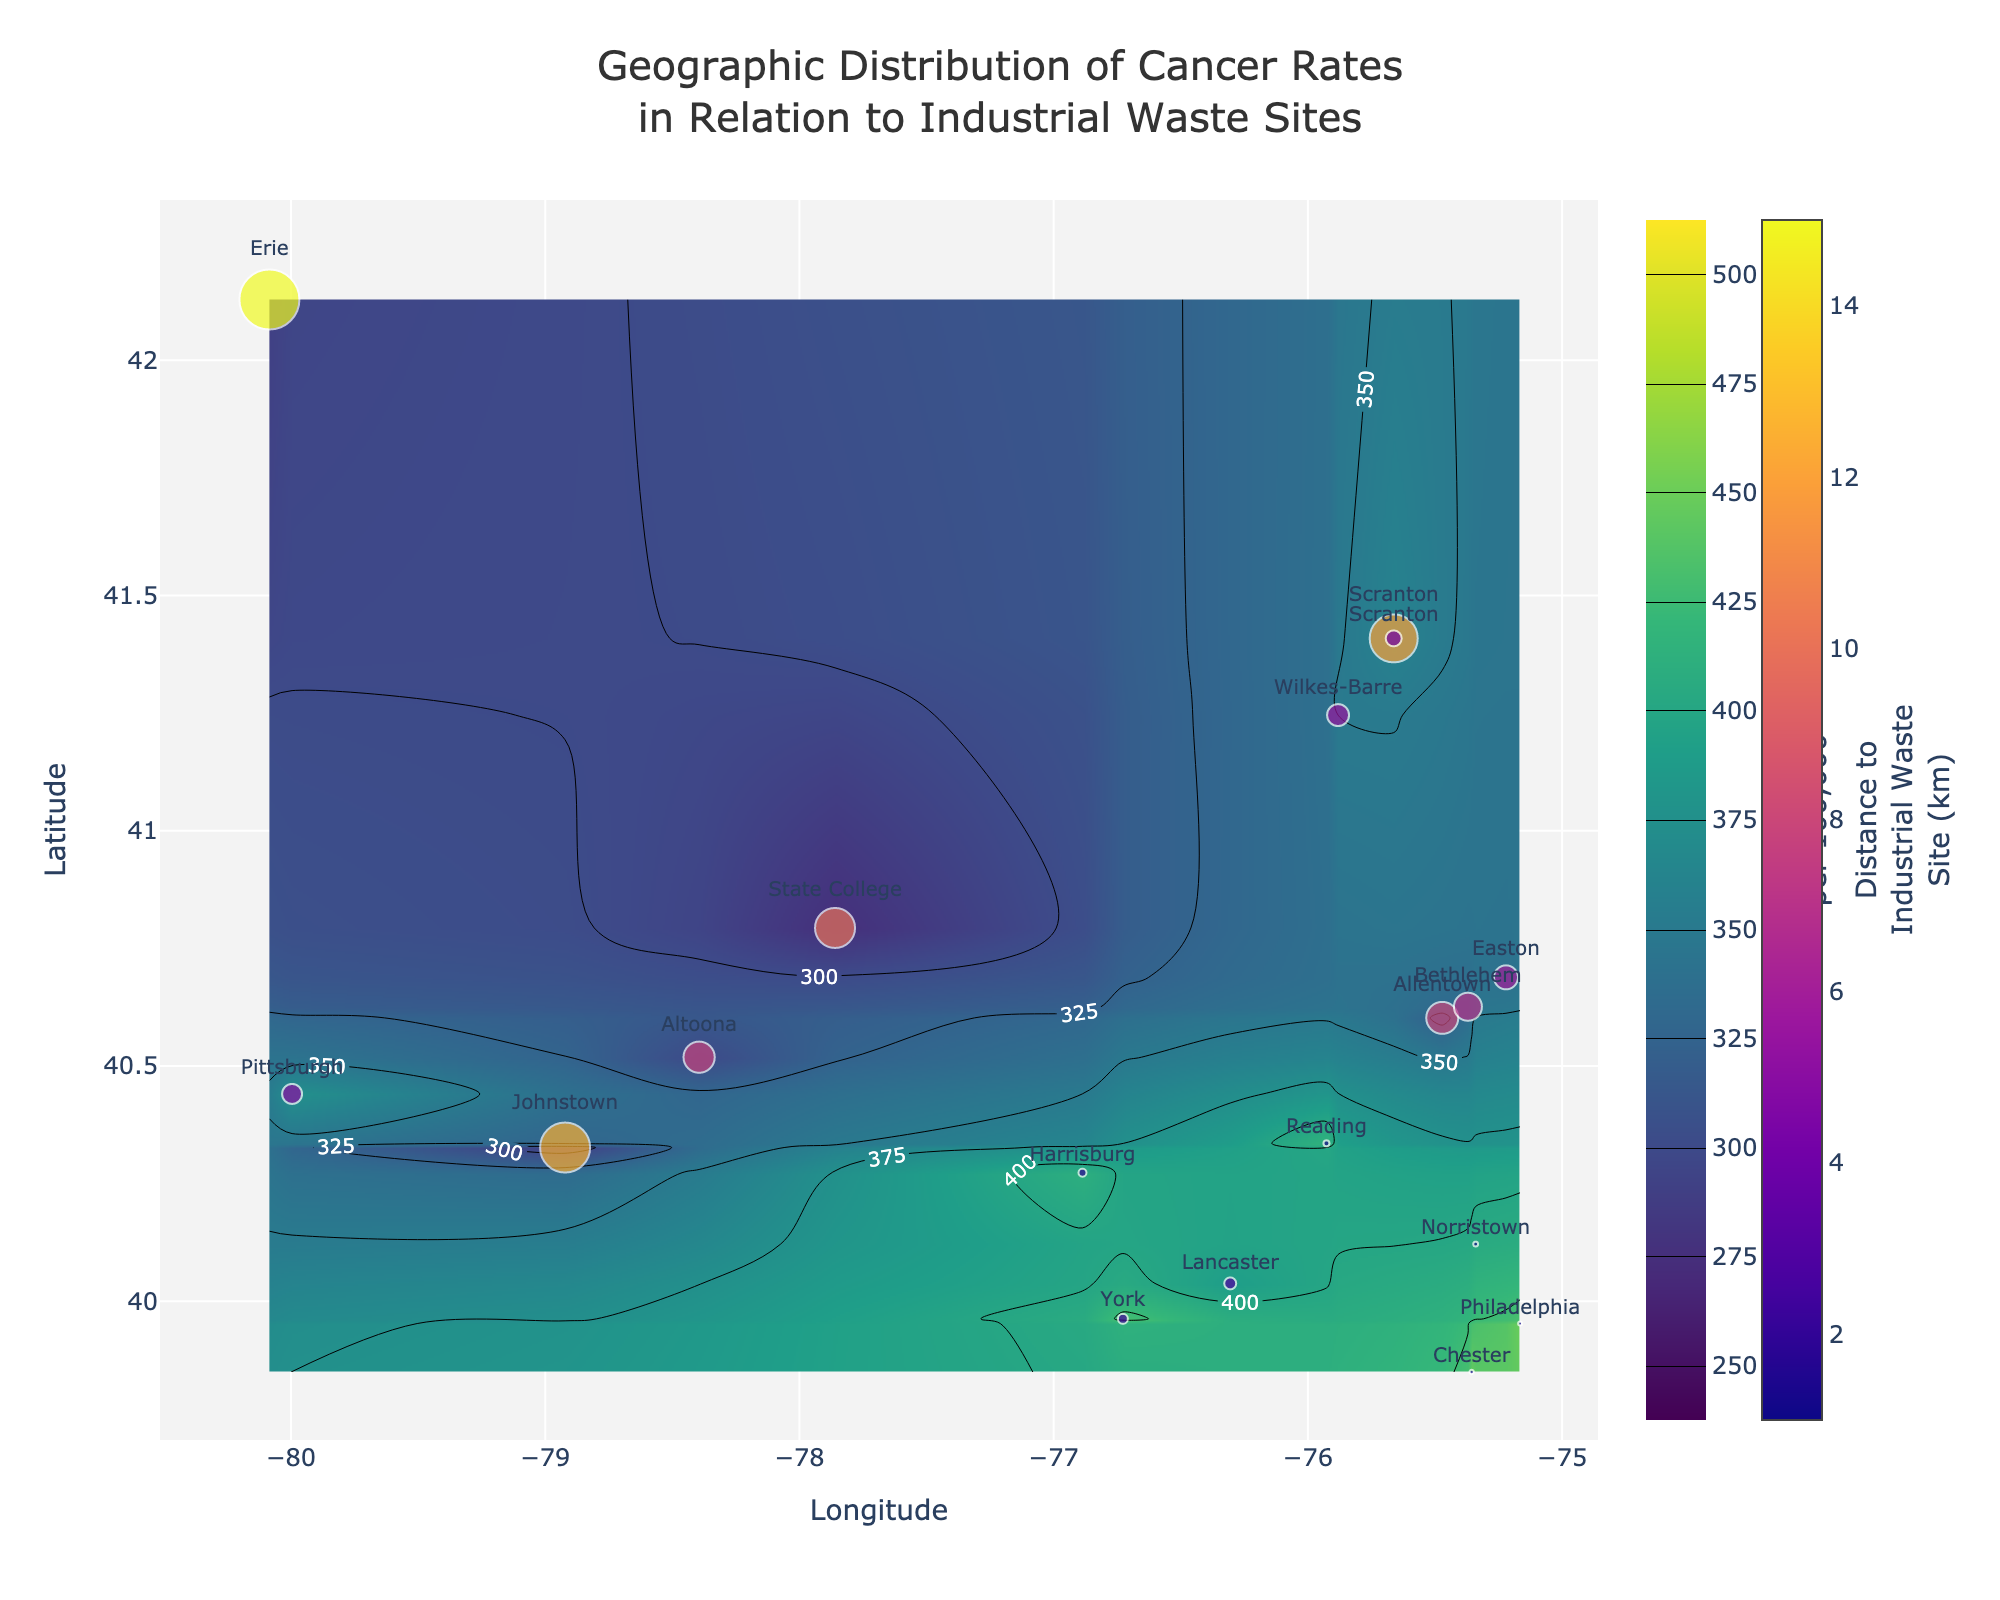What's the title of the plot? The title appears at the top center of the plot.
Answer: Geographic Distribution of Cancer Rates in Relation to Industrial Waste Sites What does the color scale represent? The color scale to the right of the contour plot indicates varying cancer rates per 100,000 people, from 250 to 500. Darker colors represent higher rates.
Answer: Cancer rates per 100,000 people Which location has the highest cancer rate? By looking at the marked points and their labels, Chester has the highest cancer rate of 445 per 100,000 people.
Answer: Chester How is the distance to industrial waste sites represented visually? The distance to industrial waste sites is represented by the size and color of the marker at each labeled location. Larger and differently colored markers indicate varying distances.
Answer: Size and color of the markers Which city is closest to an industrial waste site, and what is its cancer rate? By looking at the scatter plot and distances, Philadelphia and Reading have the smallest distances at 1 km and 1.5 km respectively. Philadelphia has a cancer rate of 450 per 100,000, while Reading is 415.
Answer: Philadelphia, 450 per 100,000 What is the average cancer rate of locations within 3 km of an industrial waste site? The locations within 3 km are Harrisburg (410), Philadelphia (450), Reading (415), Lancaster (390), and York (430). Adding these values and dividing by 5: (410+450+415+390+430)/5 = 2095/5 = 419.
Answer: 419 per 100,000 Is there a visible trend between proximity to industrial waste sites and cancer rates? By observing the map, it seems that areas closer to industrial waste sites have higher cancer rates, as indicated by higher values near smaller, colored markers.
Answer: Yes Which city has the lowest cancer rate and how far is it from an industrial waste site? The contour plot and labels show that State College has the lowest cancer rate of 275 per 100,000 and is 10 km away from an industrial waste site.
Answer: State College, 10 km 